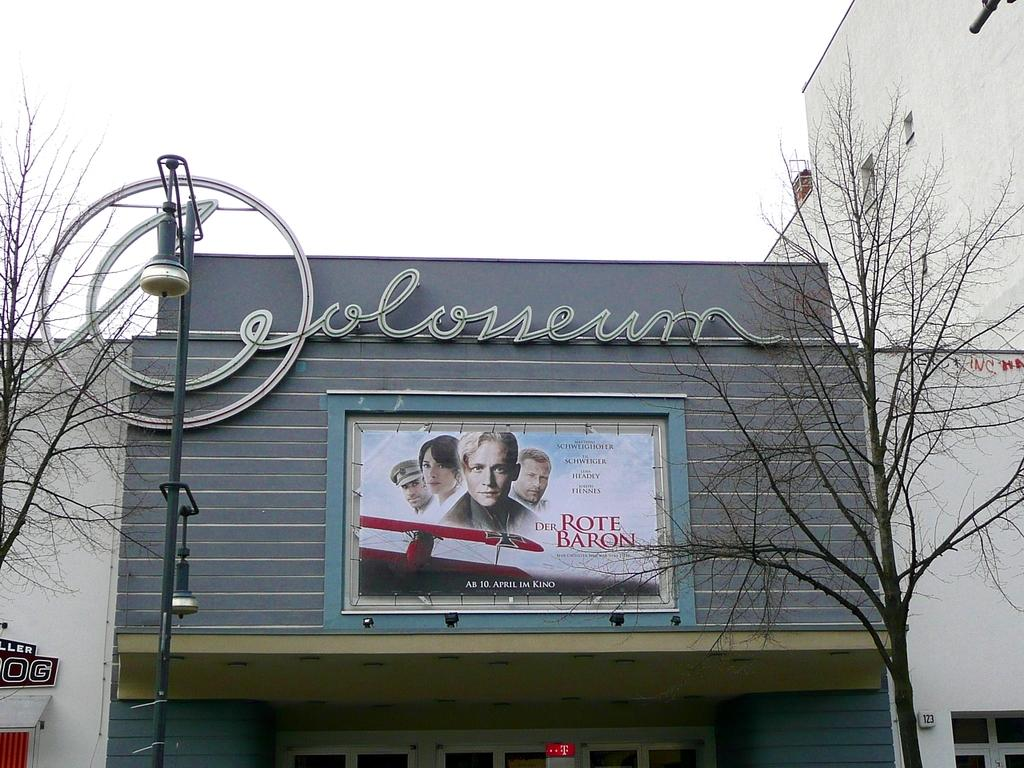<image>
Share a concise interpretation of the image provided. Coloseum of a theater showing DER Rote Baron on April 10. 